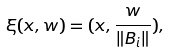<formula> <loc_0><loc_0><loc_500><loc_500>\xi ( x , w ) = ( x , \frac { w } { \| B _ { i } \| } ) , \,</formula> 